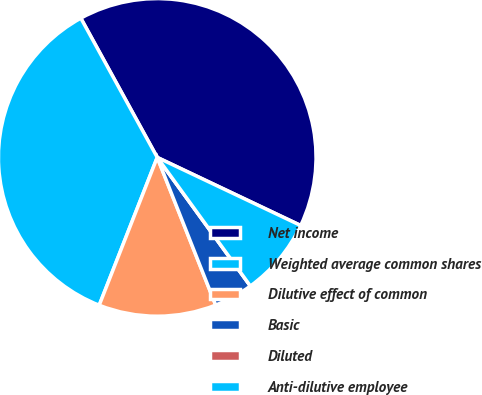<chart> <loc_0><loc_0><loc_500><loc_500><pie_chart><fcel>Net income<fcel>Weighted average common shares<fcel>Dilutive effect of common<fcel>Basic<fcel>Diluted<fcel>Anti-dilutive employee<nl><fcel>40.04%<fcel>36.06%<fcel>11.95%<fcel>3.98%<fcel>0.0%<fcel>7.97%<nl></chart> 